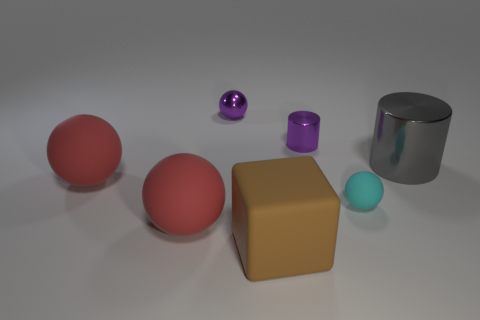Are the purple cylinder and the big red ball that is behind the tiny cyan rubber ball made of the same material?
Provide a short and direct response. No. There is a small thing that is the same color as the metal sphere; what is its material?
Make the answer very short. Metal. Does the metal ball have the same color as the small shiny cylinder?
Your response must be concise. Yes. There is a large thing that is the same material as the purple cylinder; what shape is it?
Your response must be concise. Cylinder. Are there any other things of the same color as the shiny sphere?
Your answer should be very brief. Yes. What is the color of the matte ball to the right of the tiny purple thing in front of the purple metallic ball?
Provide a short and direct response. Cyan. What is the material of the cylinder that is behind the shiny cylinder that is on the right side of the purple shiny thing that is right of the big rubber cube?
Ensure brevity in your answer.  Metal. What number of red objects have the same size as the gray shiny object?
Offer a very short reply. 2. There is a big thing that is both behind the big brown cube and in front of the small cyan rubber object; what material is it made of?
Provide a short and direct response. Rubber. How many small balls are left of the tiny purple metal ball?
Make the answer very short. 0. 